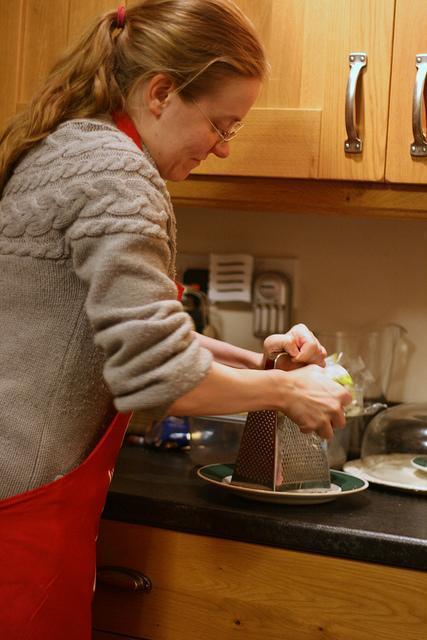How many cups are in the picture?
Give a very brief answer. 1. How many cats have their eyes closed?
Give a very brief answer. 0. 